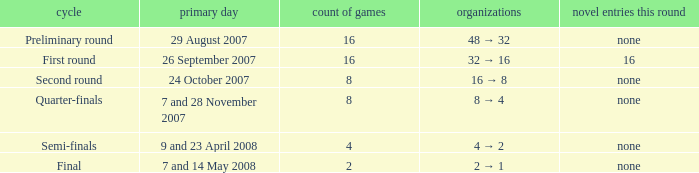Can you parse all the data within this table? {'header': ['cycle', 'primary day', 'count of games', 'organizations', 'novel entries this round'], 'rows': [['Preliminary round', '29 August 2007', '16', '48 → 32', 'none'], ['First round', '26 September 2007', '16', '32 → 16', '16'], ['Second round', '24 October 2007', '8', '16 → 8', 'none'], ['Quarter-finals', '7 and 28 November 2007', '8', '8 → 4', 'none'], ['Semi-finals', '9 and 23 April 2008', '4', '4 → 2', 'none'], ['Final', '7 and 14 May 2008', '2', '2 → 1', 'none']]} What is the Round when the number of fixtures is more than 2, and the Main date of 7 and 28 november 2007? Quarter-finals. 